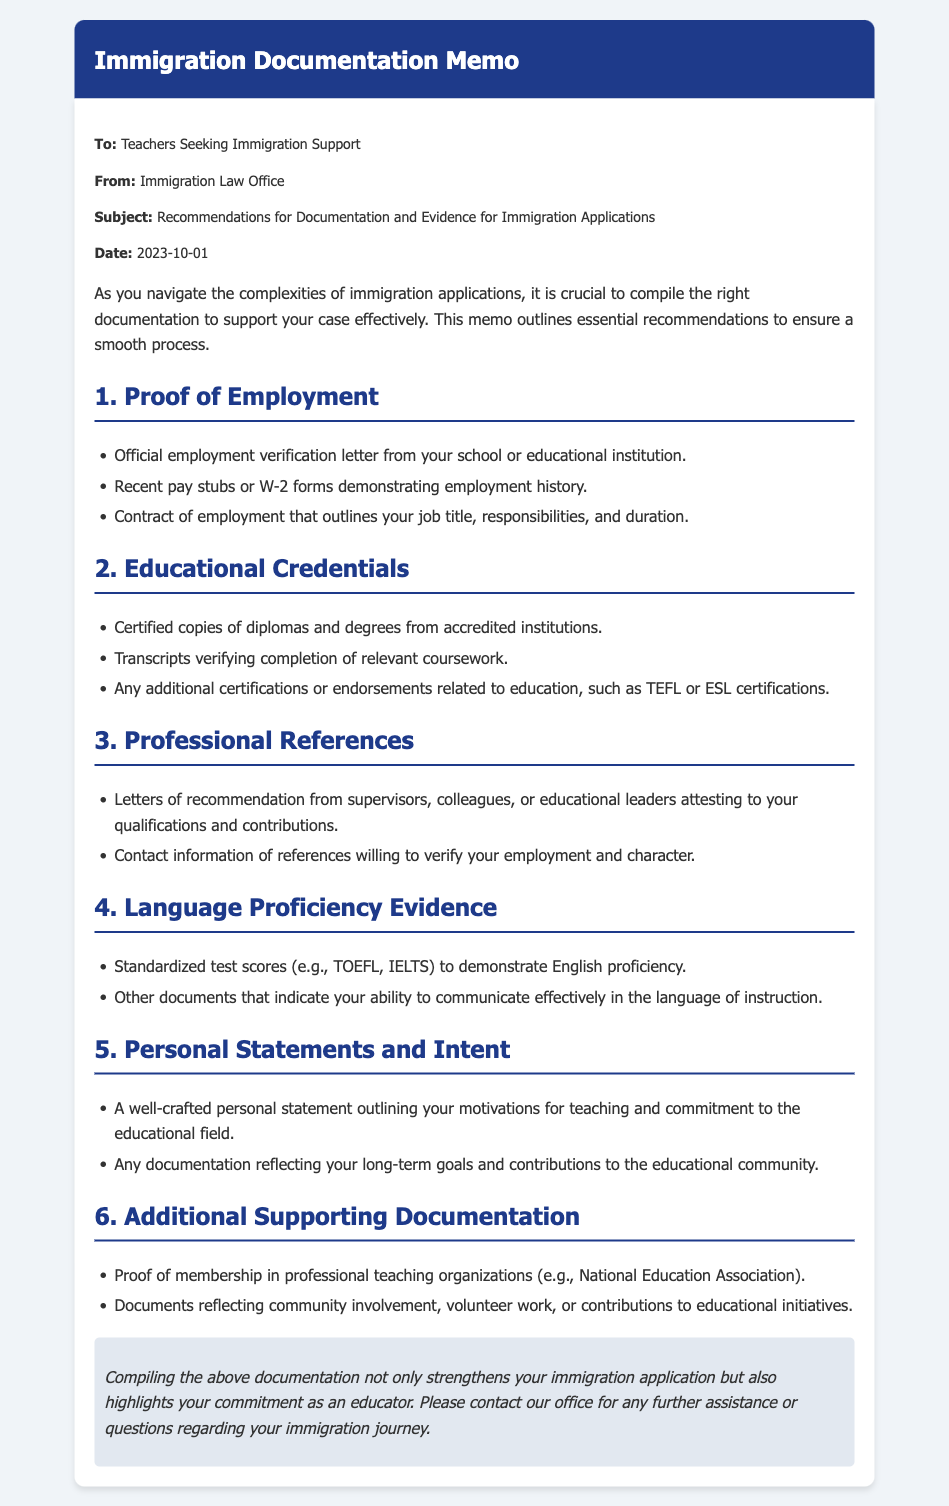What is the subject of the memo? The subject is clearly stated in the document to help understand the focus of the memo, which is recommendations for documentation and evidence for immigration applications.
Answer: Recommendations for Documentation and Evidence for Immigration Applications Who is the memo addressed to? The document specifies the audience to clarify who the recommendations are intended for in order to direct their efforts accordingly.
Answer: Teachers Seeking Immigration Support What date was the memo issued? The date is mentioned to indicate when the information was provided, which is important for understanding its timeliness.
Answer: 2023-10-01 What type of evidence is needed for educational credentials? This question pulls from the specific section of the document detailing what is required to validate educational background.
Answer: Certified copies of diplomas and degrees from accredited institutions What should the personal statement outline? This question requires an understanding of the content of the personal statements mentioned, specifying what teachers should convey about themselves.
Answer: Motivations for teaching and commitment to the educational field How many sections are there in the document? This inquiry requires counting distinct sections under the recommendations provided in the memo, highlighting the organization of content.
Answer: 6 What kind of test scores are recommended for language proficiency evidence? The memo explicitly mentions the standardized tests that can serve as evidence for a teacher's language skills.
Answer: TOEFL, IELTS What type of references should teachers obtain? This question looks for specific requirements concerning references and what qualifies as valuable testimonials for the applications.
Answer: Letters of recommendation from supervisors, colleagues, or educational leaders What is the conclusion's purpose in the memo? This question focuses on the wrapping up statements made at the end of the document, assessing the overall advocacy reflected in the conclusion.
Answer: Strengthens your immigration application and highlights your commitment as an educator 